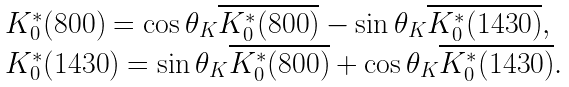Convert formula to latex. <formula><loc_0><loc_0><loc_500><loc_500>\begin{array} { l } K _ { 0 } ^ { * } ( 8 0 0 ) = \cos \theta _ { K } \overline { K _ { 0 } ^ { * } ( 8 0 0 ) } - \sin \theta _ { K } \overline { K _ { 0 } ^ { * } ( 1 4 3 0 ) } , \\ K _ { 0 } ^ { * } ( 1 4 3 0 ) = \sin \theta _ { K } \overline { K _ { 0 } ^ { * } ( 8 0 0 ) } + \cos \theta _ { K } \overline { K _ { 0 } ^ { * } ( 1 4 3 0 ) } . \end{array}</formula> 